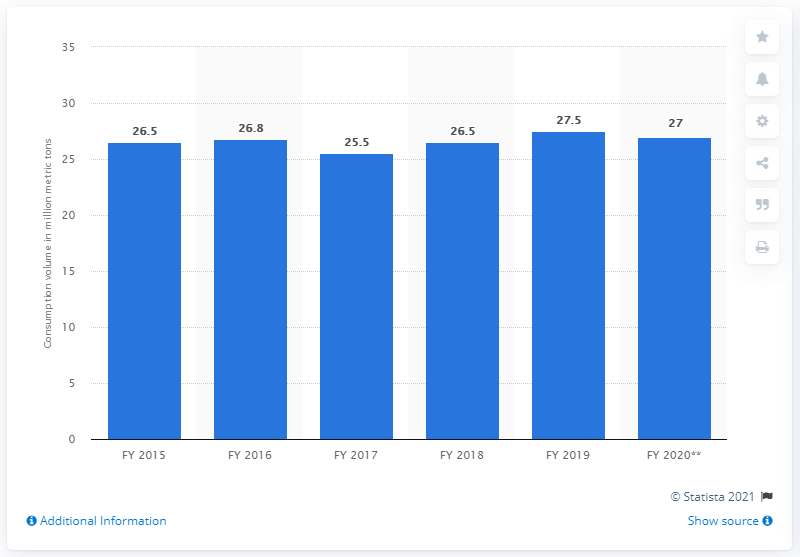Highlight a few significant elements in this photo. In 2013, the consumption volume of sugar in India was approximately 27 million metric tons. 